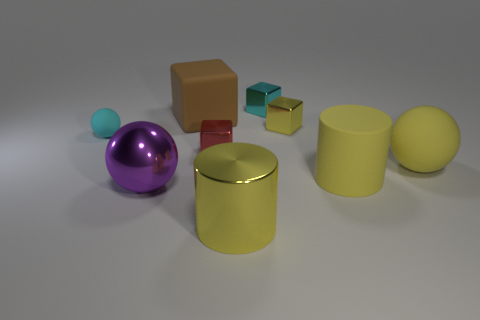Subtract all cyan spheres. How many spheres are left? 2 Subtract all cylinders. How many objects are left? 7 Add 1 gray matte balls. How many objects exist? 10 Subtract all brown blocks. How many blocks are left? 3 Subtract 1 cyan cubes. How many objects are left? 8 Subtract 2 cubes. How many cubes are left? 2 Subtract all green cubes. Subtract all green spheres. How many cubes are left? 4 Subtract all gray cubes. How many red cylinders are left? 0 Subtract all big brown rubber things. Subtract all big green objects. How many objects are left? 8 Add 5 big rubber cylinders. How many big rubber cylinders are left? 6 